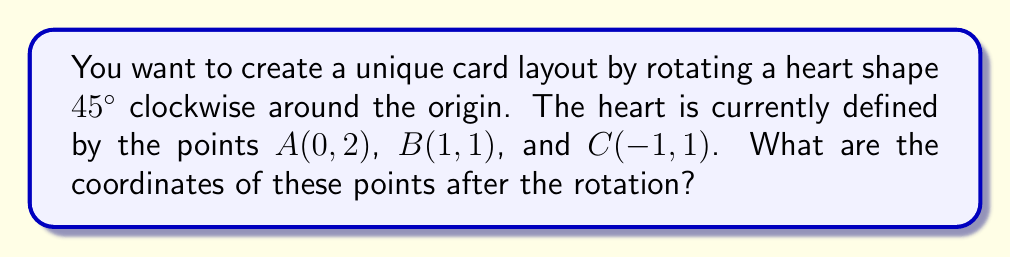Show me your answer to this math problem. To rotate a point $(x,y)$ by an angle $\theta$ counterclockwise around the origin, we use the rotation matrix:

$$\begin{bmatrix} \cos\theta & -\sin\theta \\ \sin\theta & \cos\theta \end{bmatrix}$$

Since we're rotating 45° clockwise, we'll use $\theta = -45°$ or $-\frac{\pi}{4}$ radians.

For a 45° rotation, $\cos(-45°) = \frac{\sqrt{2}}{2}$ and $\sin(-45°) = -\frac{\sqrt{2}}{2}$

Our rotation matrix becomes:

$$\begin{bmatrix} \frac{\sqrt{2}}{2} & \frac{\sqrt{2}}{2} \\ -\frac{\sqrt{2}}{2} & \frac{\sqrt{2}}{2} \end{bmatrix}$$

Now, let's rotate each point:

1. Point A(0,2):
   $$\begin{bmatrix} \frac{\sqrt{2}}{2} & \frac{\sqrt{2}}{2} \\ -\frac{\sqrt{2}}{2} & \frac{\sqrt{2}}{2} \end{bmatrix} \begin{bmatrix} 0 \\ 2 \end{bmatrix} = \begin{bmatrix} \sqrt{2} \\ \sqrt{2} \end{bmatrix}$$

2. Point B(1,1):
   $$\begin{bmatrix} \frac{\sqrt{2}}{2} & \frac{\sqrt{2}}{2} \\ -\frac{\sqrt{2}}{2} & \frac{\sqrt{2}}{2} \end{bmatrix} \begin{bmatrix} 1 \\ 1 \end{bmatrix} = \begin{bmatrix} \sqrt{2} \\ 0 \end{bmatrix}$$

3. Point C(-1,1):
   $$\begin{bmatrix} \frac{\sqrt{2}}{2} & \frac{\sqrt{2}}{2} \\ -\frac{\sqrt{2}}{2} & \frac{\sqrt{2}}{2} \end{bmatrix} \begin{bmatrix} -1 \\ 1 \end{bmatrix} = \begin{bmatrix} 0 \\ \sqrt{2} \end{bmatrix}$$
Answer: After rotation, the new coordinates are:
A: $(\sqrt{2}, \sqrt{2})$
B: $(\sqrt{2}, 0)$
C: $(0, \sqrt{2})$ 